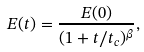Convert formula to latex. <formula><loc_0><loc_0><loc_500><loc_500>E ( t ) = \frac { E ( 0 ) } { ( 1 + t / t _ { c } ) ^ { \beta } } ,</formula> 